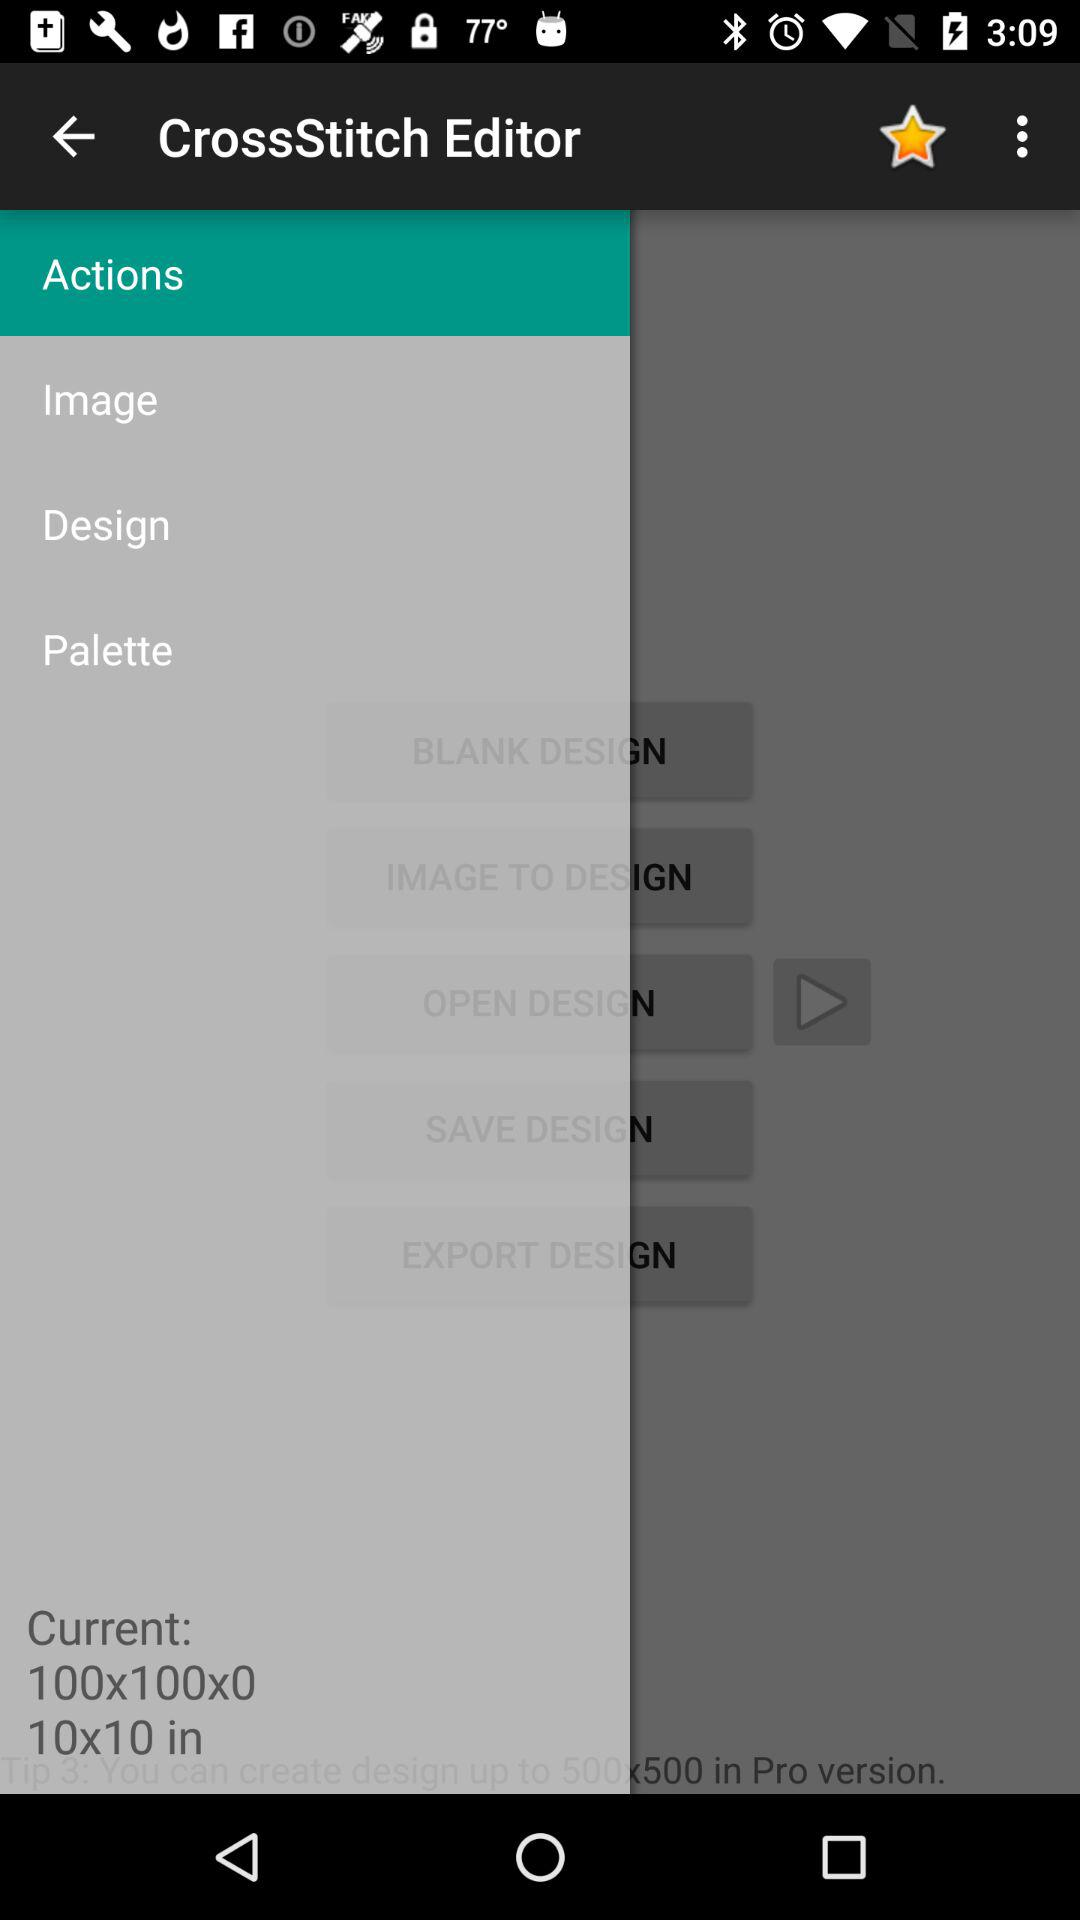What is the name of the application? The name of the application is "CrossStitch Editor". 